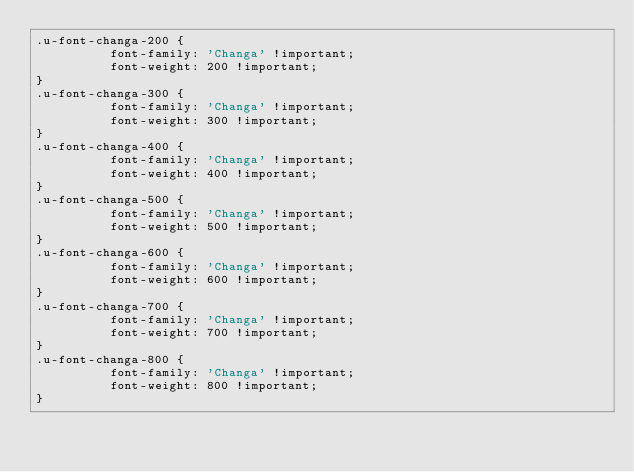<code> <loc_0><loc_0><loc_500><loc_500><_CSS_>.u-font-changa-200 {
          font-family: 'Changa' !important;
          font-weight: 200 !important;
}
.u-font-changa-300 {
          font-family: 'Changa' !important;
          font-weight: 300 !important;
}
.u-font-changa-400 {
          font-family: 'Changa' !important;
          font-weight: 400 !important;
}
.u-font-changa-500 {
          font-family: 'Changa' !important;
          font-weight: 500 !important;
}
.u-font-changa-600 {
          font-family: 'Changa' !important;
          font-weight: 600 !important;
}
.u-font-changa-700 {
          font-family: 'Changa' !important;
          font-weight: 700 !important;
}
.u-font-changa-800 {
          font-family: 'Changa' !important;
          font-weight: 800 !important;
}</code> 